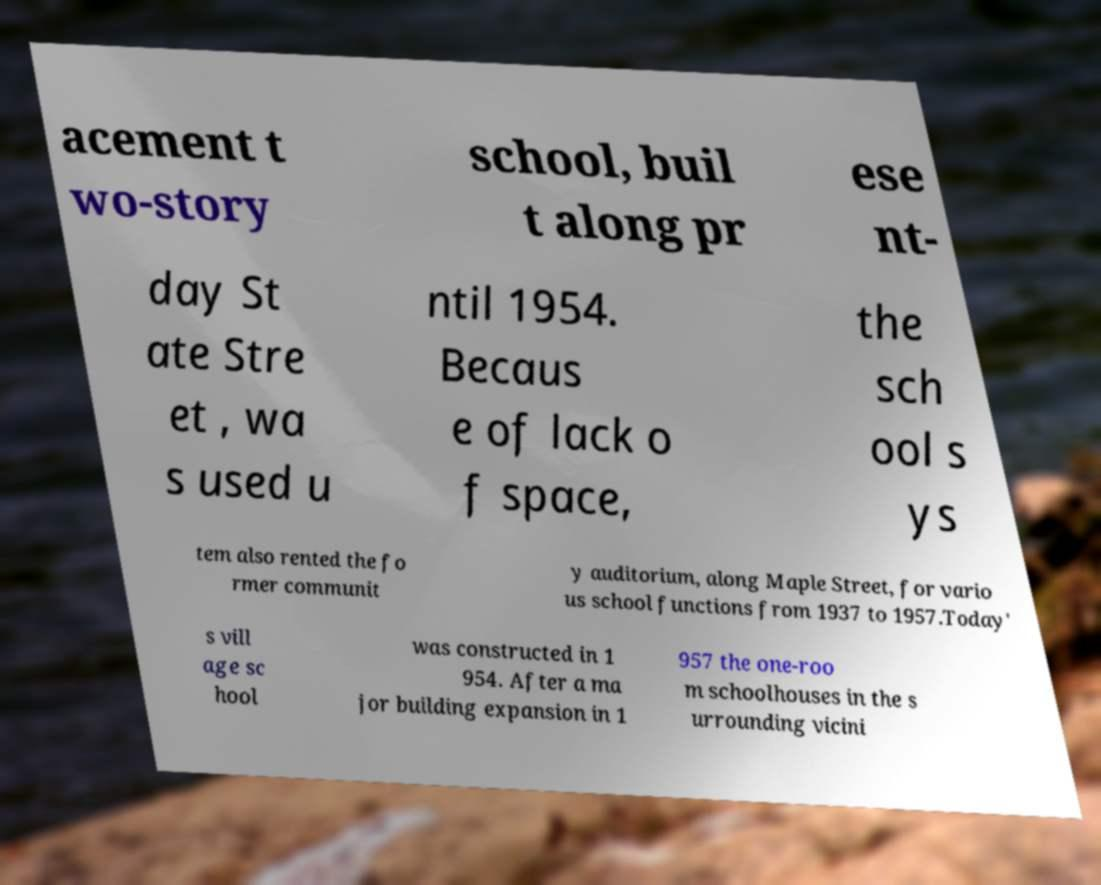There's text embedded in this image that I need extracted. Can you transcribe it verbatim? acement t wo-story school, buil t along pr ese nt- day St ate Stre et , wa s used u ntil 1954. Becaus e of lack o f space, the sch ool s ys tem also rented the fo rmer communit y auditorium, along Maple Street, for vario us school functions from 1937 to 1957.Today' s vill age sc hool was constructed in 1 954. After a ma jor building expansion in 1 957 the one-roo m schoolhouses in the s urrounding vicini 